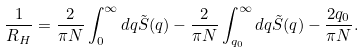<formula> <loc_0><loc_0><loc_500><loc_500>\frac { 1 } { R _ { H } } = \frac { 2 } { \pi N } \int _ { 0 } ^ { \infty } d q \tilde { S } ( q ) - \frac { 2 } { \pi N } \int _ { q _ { 0 } } ^ { \infty } d q \tilde { S } ( q ) - \frac { 2 q _ { 0 } } { \pi N } .</formula> 